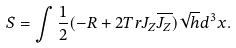Convert formula to latex. <formula><loc_0><loc_0><loc_500><loc_500>S = \int \frac { 1 } { 2 } ( - R + 2 T r J _ { Z } \overline { J _ { Z } } ) \sqrt { h } d ^ { 3 } x .</formula> 